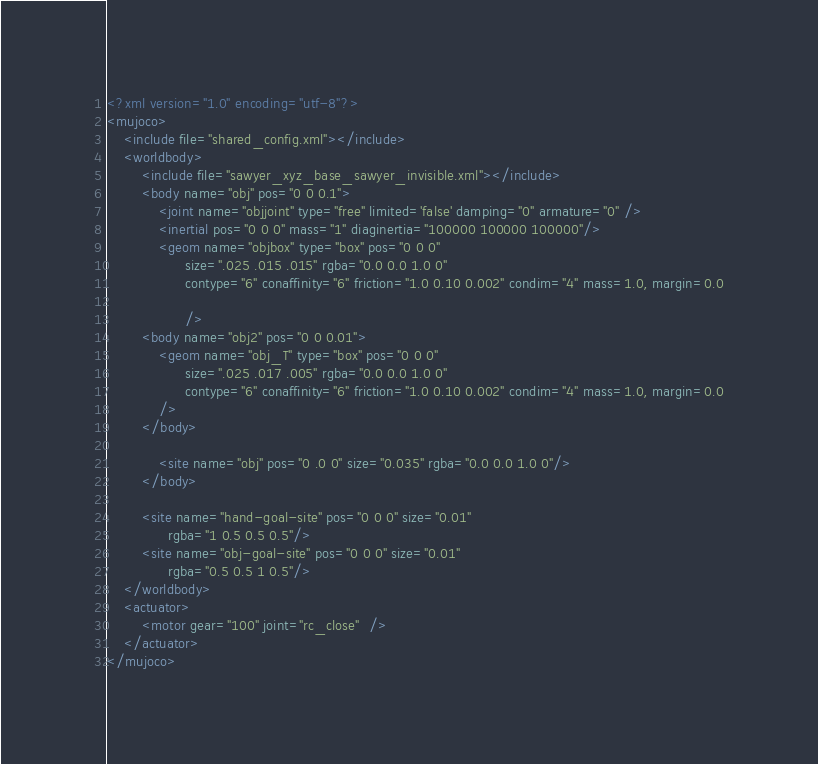<code> <loc_0><loc_0><loc_500><loc_500><_XML_><?xml version="1.0" encoding="utf-8"?>
<mujoco>
    <include file="shared_config.xml"></include>
    <worldbody>
        <include file="sawyer_xyz_base_sawyer_invisible.xml"></include>
        <body name="obj" pos="0 0 0.1">
            <joint name="objjoint" type="free" limited='false' damping="0" armature="0" />
            <inertial pos="0 0 0" mass="1" diaginertia="100000 100000 100000"/>
            <geom name="objbox" type="box" pos="0 0 0"
                  size=".025 .015 .015" rgba="0.0 0.0 1.0 0"
                  contype="6" conaffinity="6" friction="1.0 0.10 0.002" condim="4" mass=1.0, margin=0.0

                  />
        <body name="obj2" pos="0 0 0.01">
            <geom name="obj_T" type="box" pos="0 0 0"
                  size=".025 .017 .005" rgba="0.0 0.0 1.0 0"
                  contype="6" conaffinity="6" friction="1.0 0.10 0.002" condim="4" mass=1.0, margin=0.0
            />
        </body>

            <site name="obj" pos="0 .0 0" size="0.035" rgba="0.0 0.0 1.0 0"/>
        </body>

        <site name="hand-goal-site" pos="0 0 0" size="0.01"
              rgba="1 0.5 0.5 0.5"/>
        <site name="obj-goal-site" pos="0 0 0" size="0.01"
              rgba="0.5 0.5 1 0.5"/>
    </worldbody>
    <actuator>
        <motor gear="100" joint="rc_close"  />
    </actuator>
</mujoco>
</code> 